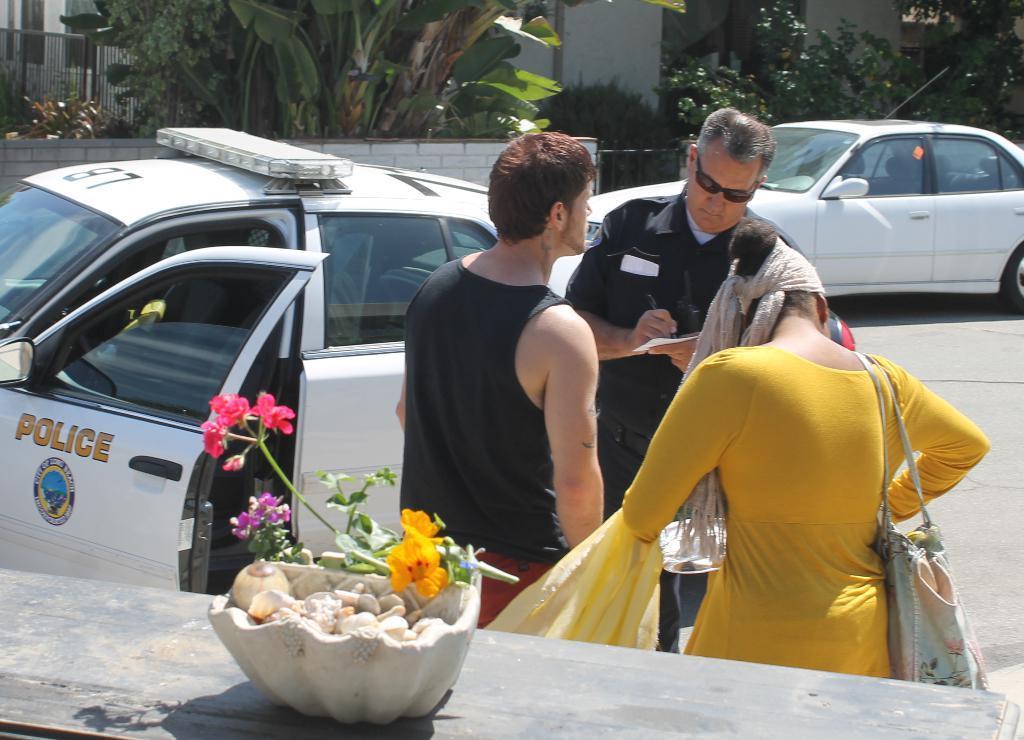How would you summarize this image in a sentence or two? In this image I can see there are two vehicles and three persons and a woman carrying a bag visible on road ,at the bottom I can see table , on the table I can see a flower pot and in the flower pot there are stones ,flowers visible and I can see trees, bushes ,fence at the top. 